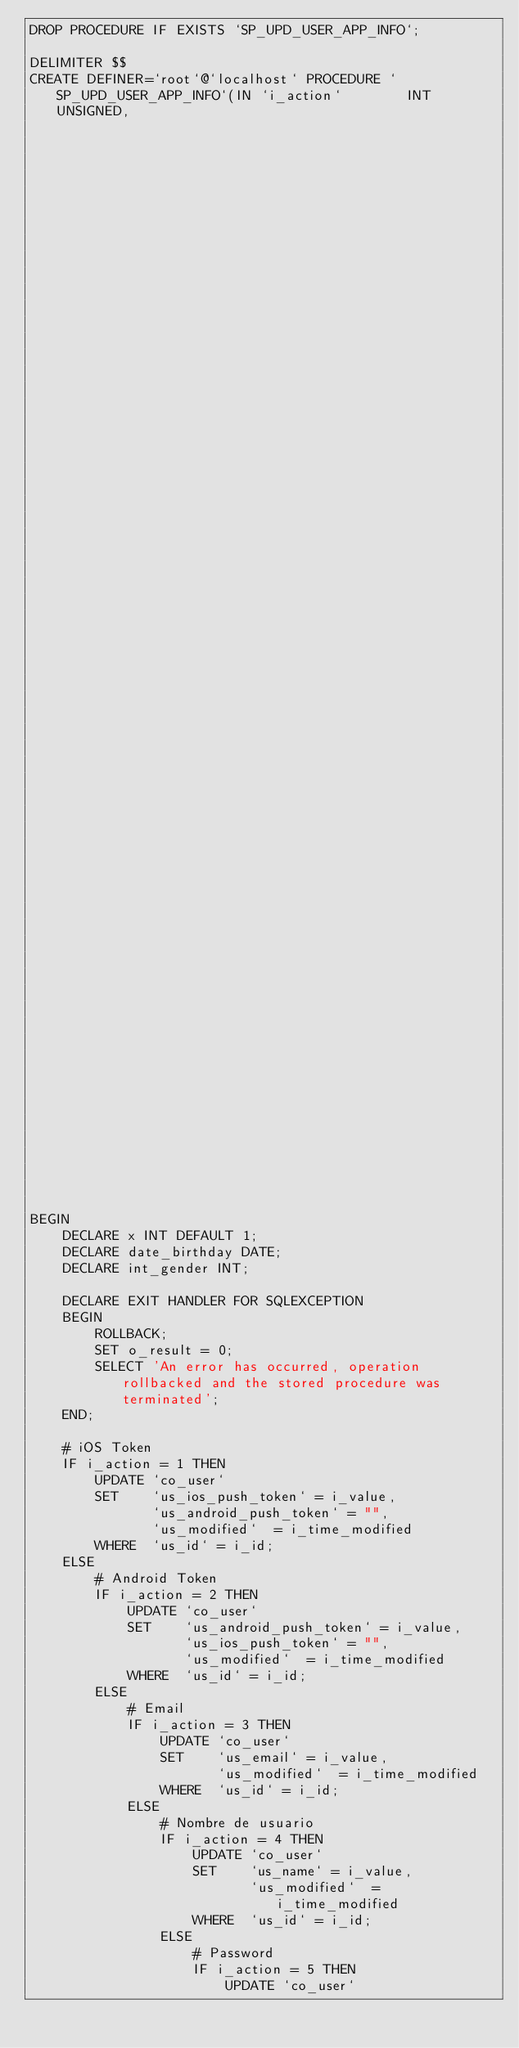<code> <loc_0><loc_0><loc_500><loc_500><_SQL_>DROP PROCEDURE IF EXISTS `SP_UPD_USER_APP_INFO`;

DELIMITER $$
CREATE DEFINER=`root`@`localhost` PROCEDURE `SP_UPD_USER_APP_INFO`(IN `i_action`        INT UNSIGNED,
                                                                   IN `i_id`            INT UNSIGNED,
                                                                   IN `i_time_modified` INT UNSIGNED,
                                                                   IN `i_value`         VARCHAR(255) CHARSET utf8,
                                                                   OUT `o_result`       INT UNSIGNED) NOT DETERMINISTIC READS SQL DATA SQL SECURITY DEFINER

BEGIN
    DECLARE x INT DEFAULT 1;
    DECLARE date_birthday DATE;
    DECLARE int_gender INT;
    
    DECLARE EXIT HANDLER FOR SQLEXCEPTION
    BEGIN
        ROLLBACK;
        SET o_result = 0;
        SELECT 'An error has occurred, operation rollbacked and the stored procedure was terminated';
    END;

    # iOS Token
    IF i_action = 1 THEN
        UPDATE `co_user`
        SET    `us_ios_push_token` = i_value,
               `us_android_push_token` = "",
               `us_modified`  = i_time_modified
        WHERE  `us_id` = i_id;
    ELSE
        # Android Token
        IF i_action = 2 THEN
            UPDATE `co_user`
            SET    `us_android_push_token` = i_value,
                   `us_ios_push_token` = "",
                   `us_modified`  = i_time_modified
            WHERE  `us_id` = i_id;
        ELSE
            # Email
            IF i_action = 3 THEN
                UPDATE `co_user`
                SET    `us_email` = i_value,
                       `us_modified`  = i_time_modified
                WHERE  `us_id` = i_id;
            ELSE
                # Nombre de usuario
                IF i_action = 4 THEN
                    UPDATE `co_user`
                    SET    `us_name` = i_value,
                           `us_modified`  = i_time_modified
                    WHERE  `us_id` = i_id;
                ELSE
                    # Password
                    IF i_action = 5 THEN
                        UPDATE `co_user`</code> 